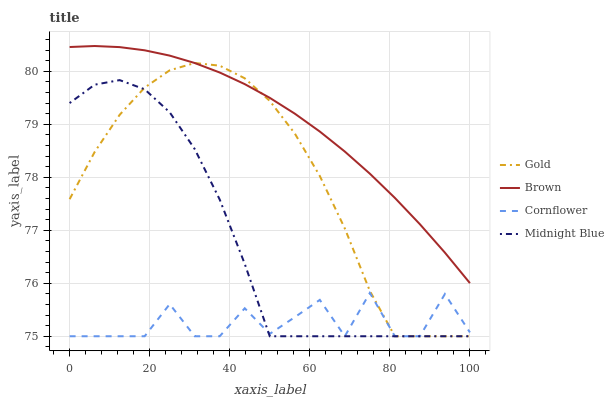Does Cornflower have the minimum area under the curve?
Answer yes or no. Yes. Does Brown have the maximum area under the curve?
Answer yes or no. Yes. Does Midnight Blue have the minimum area under the curve?
Answer yes or no. No. Does Midnight Blue have the maximum area under the curve?
Answer yes or no. No. Is Brown the smoothest?
Answer yes or no. Yes. Is Cornflower the roughest?
Answer yes or no. Yes. Is Midnight Blue the smoothest?
Answer yes or no. No. Is Midnight Blue the roughest?
Answer yes or no. No. Does Midnight Blue have the lowest value?
Answer yes or no. Yes. Does Brown have the highest value?
Answer yes or no. Yes. Does Midnight Blue have the highest value?
Answer yes or no. No. Is Cornflower less than Brown?
Answer yes or no. Yes. Is Brown greater than Midnight Blue?
Answer yes or no. Yes. Does Cornflower intersect Gold?
Answer yes or no. Yes. Is Cornflower less than Gold?
Answer yes or no. No. Is Cornflower greater than Gold?
Answer yes or no. No. Does Cornflower intersect Brown?
Answer yes or no. No. 